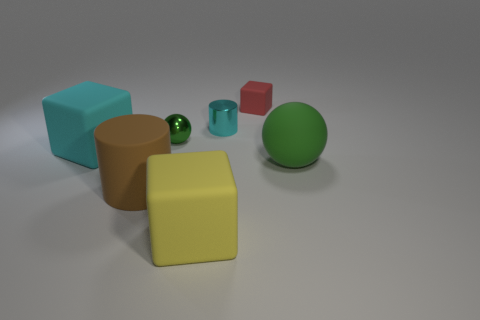How many objects are there in total in the image, and can you describe their shapes? There are five objects in total. From left to right, there's a cyan cube, a brown cylinder, a teal cylinder that's smaller in size, a red cube that's the smallest object, and a green sphere. 